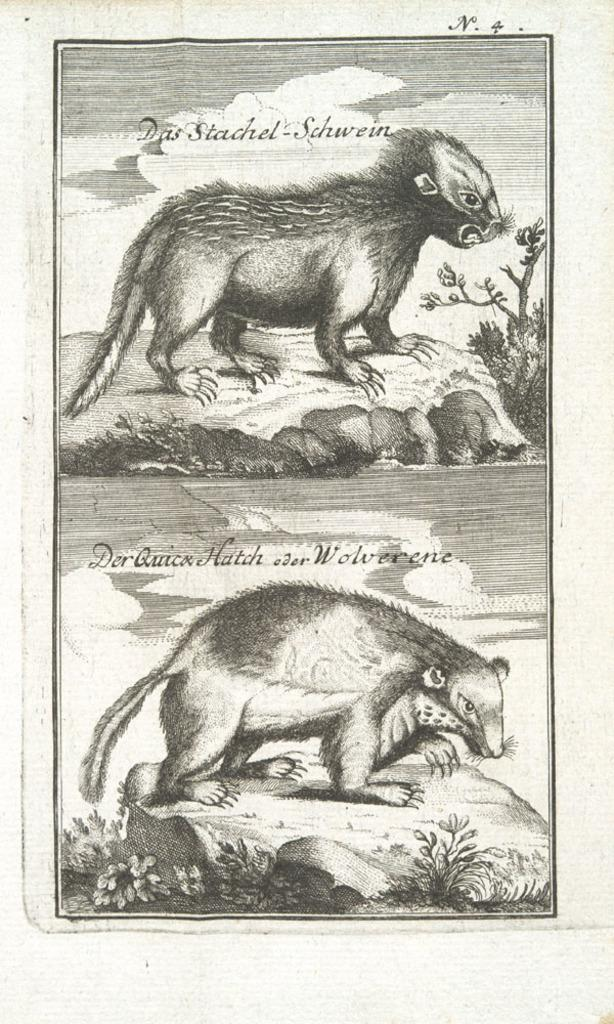What is present in the image? There is a paper in the image. What is depicted on the paper? The paper contains parts of animals. What type of plastic object can be seen on the paper? There is no plastic object present on the paper; it only contains parts of animals. 